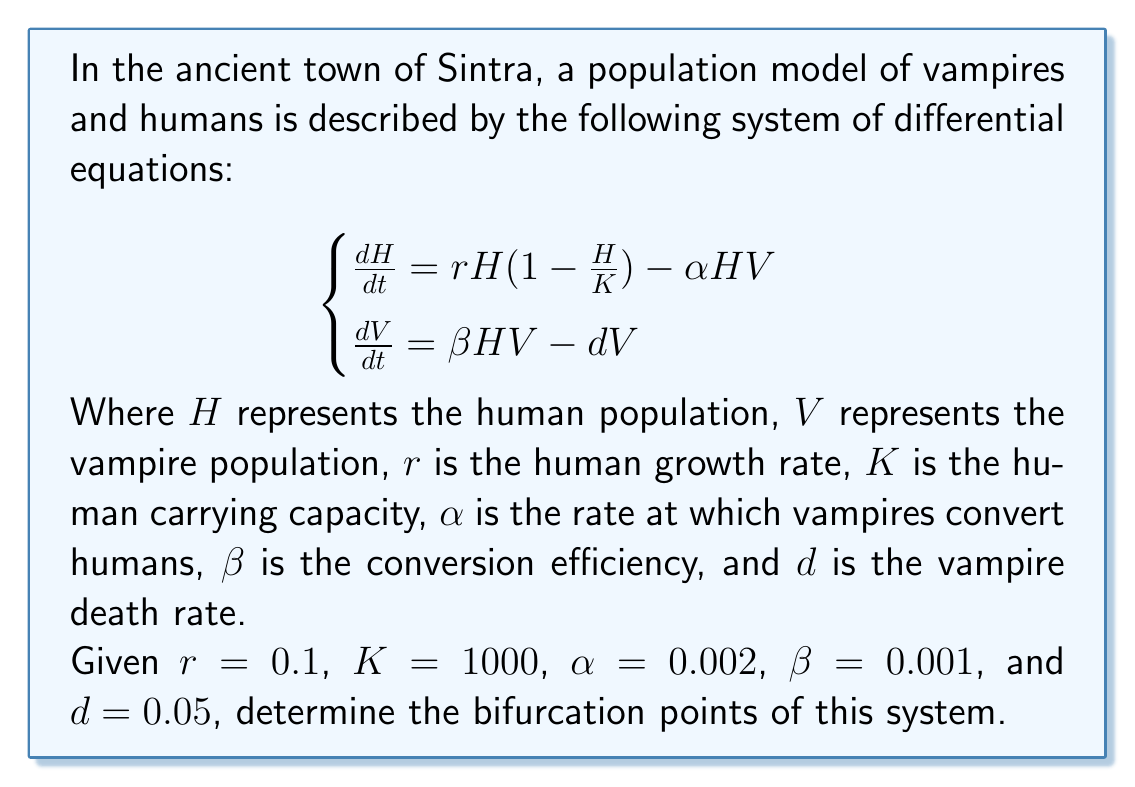Give your solution to this math problem. To find the bifurcation points, we need to follow these steps:

1) First, find the equilibrium points by setting both equations to zero:

   $$\begin{cases}
   rH(1 - \frac{H}{K}) - \alpha HV = 0 \\
   \beta HV - dV = 0
   \end{cases}$$

2) From the second equation, we can see that either $V = 0$ or $H = \frac{d}{\beta}$.

3) If $V = 0$, from the first equation we get:
   
   $$rH(1 - \frac{H}{K}) = 0$$
   
   This gives us two equilibrium points: $(H, V) = (0, 0)$ and $(H, V) = (K, 0) = (1000, 0)$.

4) If $H = \frac{d}{\beta} = \frac{0.05}{0.001} = 50$, substituting this into the first equation:

   $$r \cdot 50(1 - \frac{50}{K}) - \alpha \cdot 50V = 0$$
   $$5(1 - \frac{50}{1000}) - 0.1V = 0$$
   $$4.75 - 0.1V = 0$$
   $$V = 47.5$$

   This gives us the third equilibrium point: $(H, V) = (50, 47.5)$.

5) The bifurcation occurs when the non-trivial equilibrium point $(50, 47.5)$ becomes biologically feasible, i.e., when $\frac{d}{\beta} < K$.

6) Therefore, the bifurcation point occurs when $\frac{d}{\beta} = K$, or when $\frac{0.05}{\beta} = 1000$.

7) Solving this, we get $\beta = 0.00005$.

Thus, the bifurcation occurs when $\beta = 0.00005$, which is the critical value where the system transitions from having two equilibrium points to having three.
Answer: $\beta = 0.00005$ 